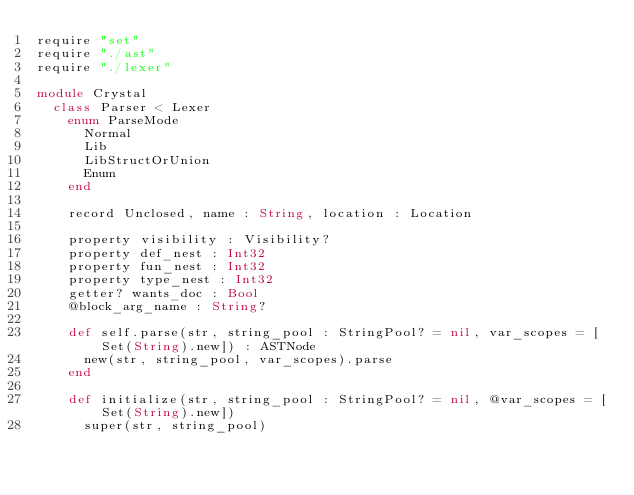Convert code to text. <code><loc_0><loc_0><loc_500><loc_500><_Crystal_>require "set"
require "./ast"
require "./lexer"

module Crystal
  class Parser < Lexer
    enum ParseMode
      Normal
      Lib
      LibStructOrUnion
      Enum
    end

    record Unclosed, name : String, location : Location

    property visibility : Visibility?
    property def_nest : Int32
    property fun_nest : Int32
    property type_nest : Int32
    getter? wants_doc : Bool
    @block_arg_name : String?

    def self.parse(str, string_pool : StringPool? = nil, var_scopes = [Set(String).new]) : ASTNode
      new(str, string_pool, var_scopes).parse
    end

    def initialize(str, string_pool : StringPool? = nil, @var_scopes = [Set(String).new])
      super(str, string_pool)</code> 